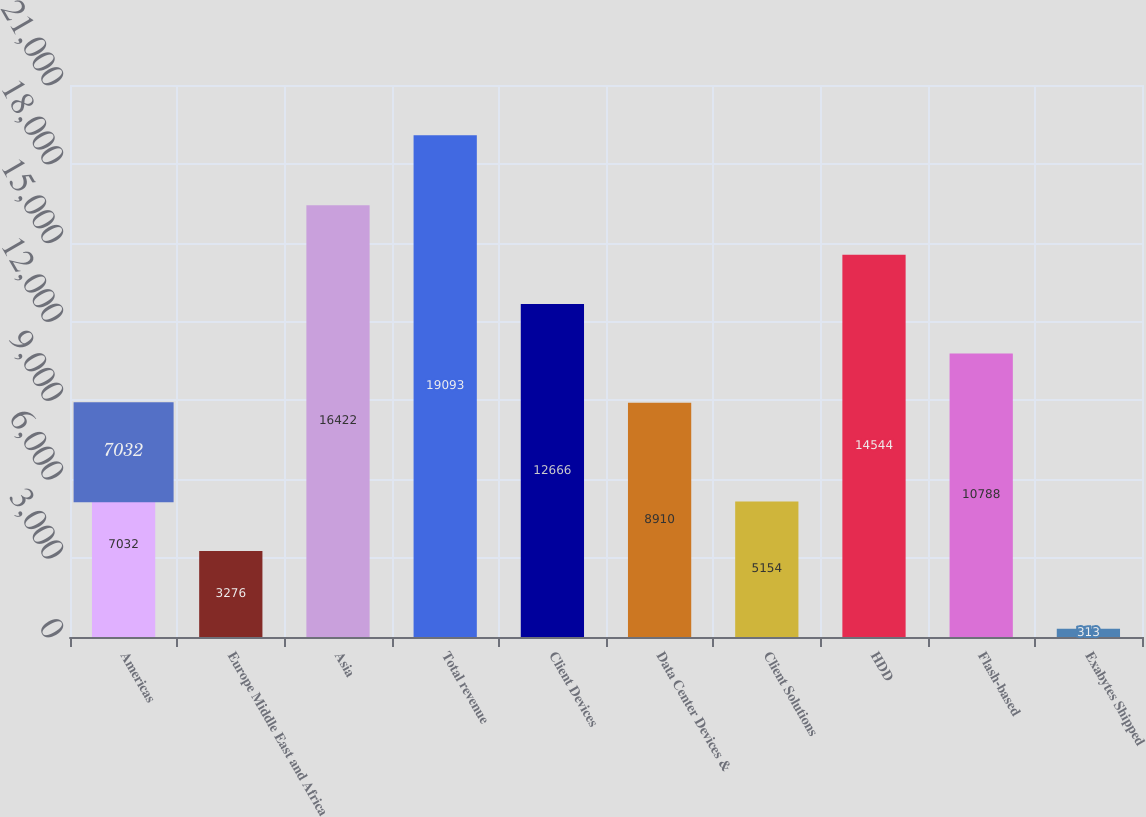Convert chart. <chart><loc_0><loc_0><loc_500><loc_500><bar_chart><fcel>Americas<fcel>Europe Middle East and Africa<fcel>Asia<fcel>Total revenue<fcel>Client Devices<fcel>Data Center Devices &<fcel>Client Solutions<fcel>HDD<fcel>Flash-based<fcel>Exabytes Shipped<nl><fcel>7032<fcel>3276<fcel>16422<fcel>19093<fcel>12666<fcel>8910<fcel>5154<fcel>14544<fcel>10788<fcel>313<nl></chart> 